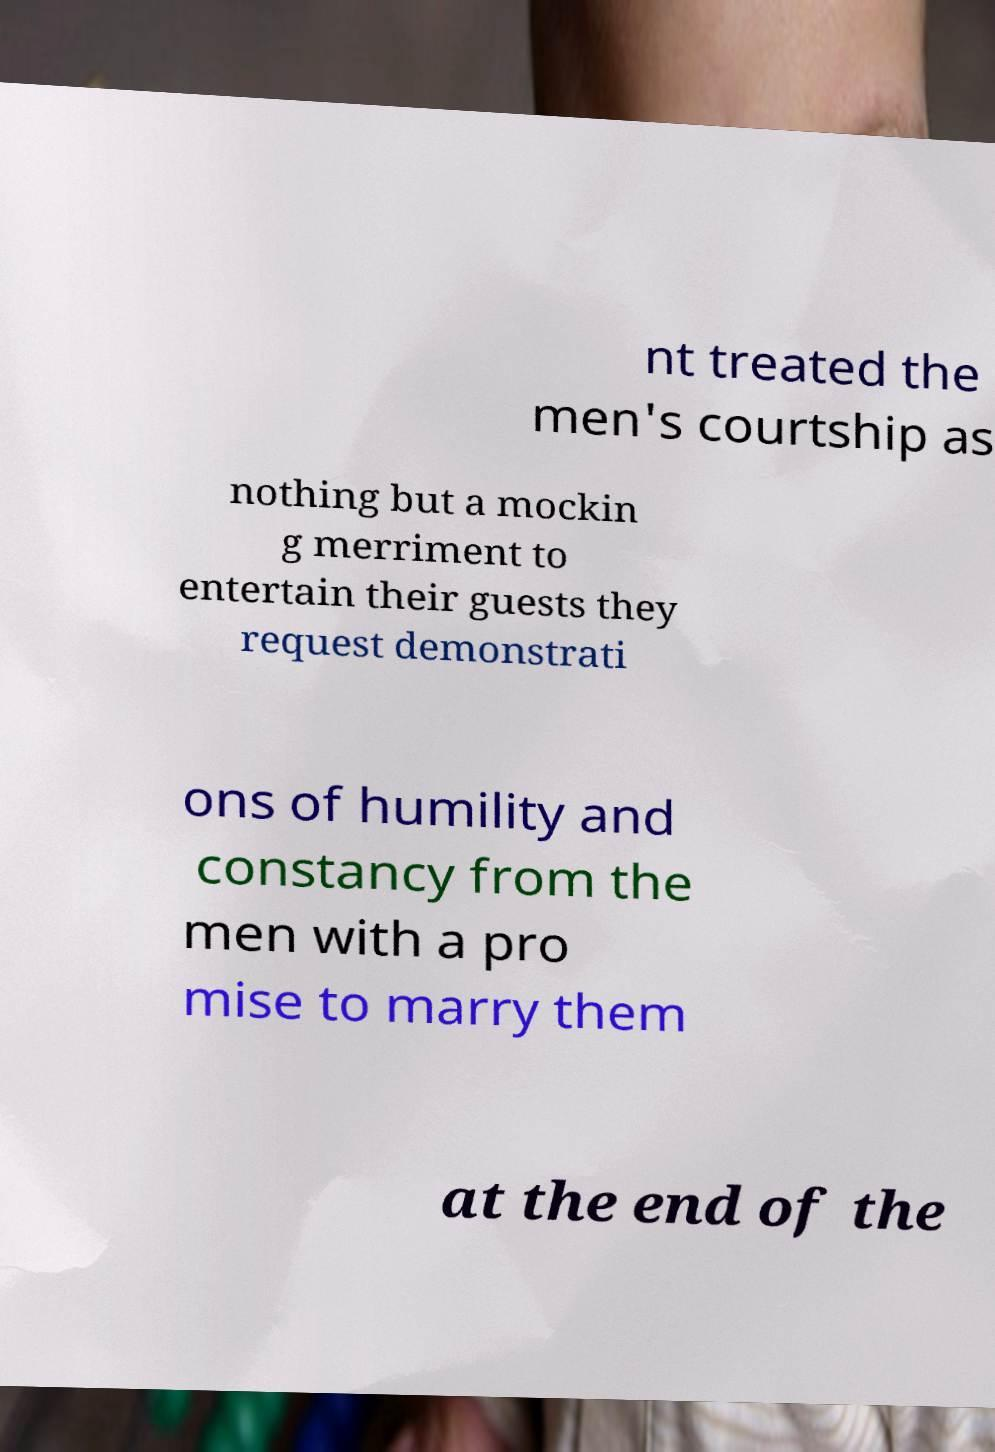Please identify and transcribe the text found in this image. nt treated the men's courtship as nothing but a mockin g merriment to entertain their guests they request demonstrati ons of humility and constancy from the men with a pro mise to marry them at the end of the 